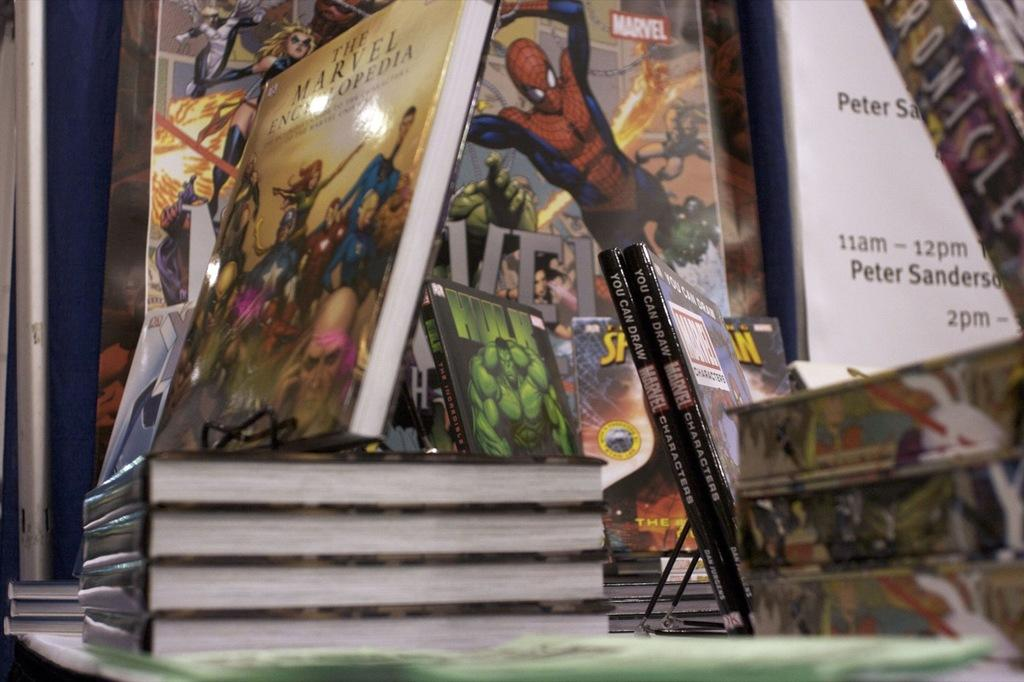<image>
Describe the image concisely. Different hardcover Marvel books are displayed on a table. 